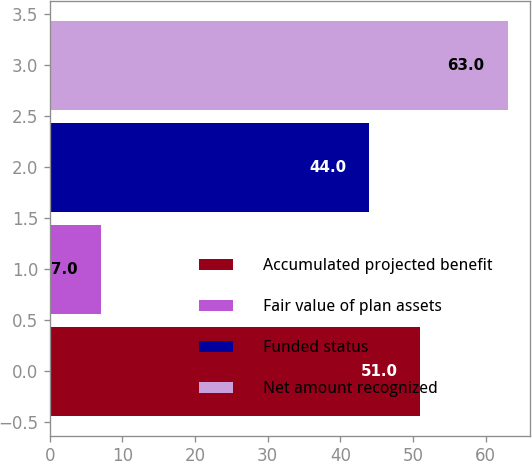<chart> <loc_0><loc_0><loc_500><loc_500><bar_chart><fcel>Accumulated projected benefit<fcel>Fair value of plan assets<fcel>Funded status<fcel>Net amount recognized<nl><fcel>51<fcel>7<fcel>44<fcel>63<nl></chart> 